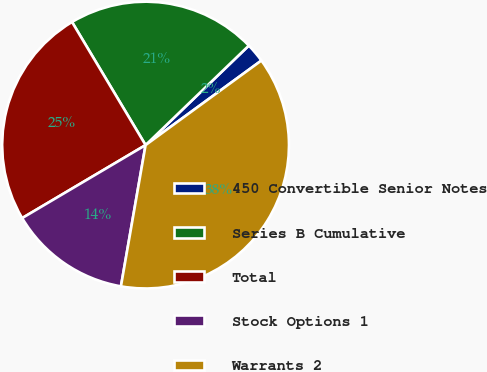Convert chart to OTSL. <chart><loc_0><loc_0><loc_500><loc_500><pie_chart><fcel>450 Convertible Senior Notes<fcel>Series B Cumulative<fcel>Total<fcel>Stock Options 1<fcel>Warrants 2<nl><fcel>2.17%<fcel>21.37%<fcel>24.93%<fcel>13.75%<fcel>37.79%<nl></chart> 